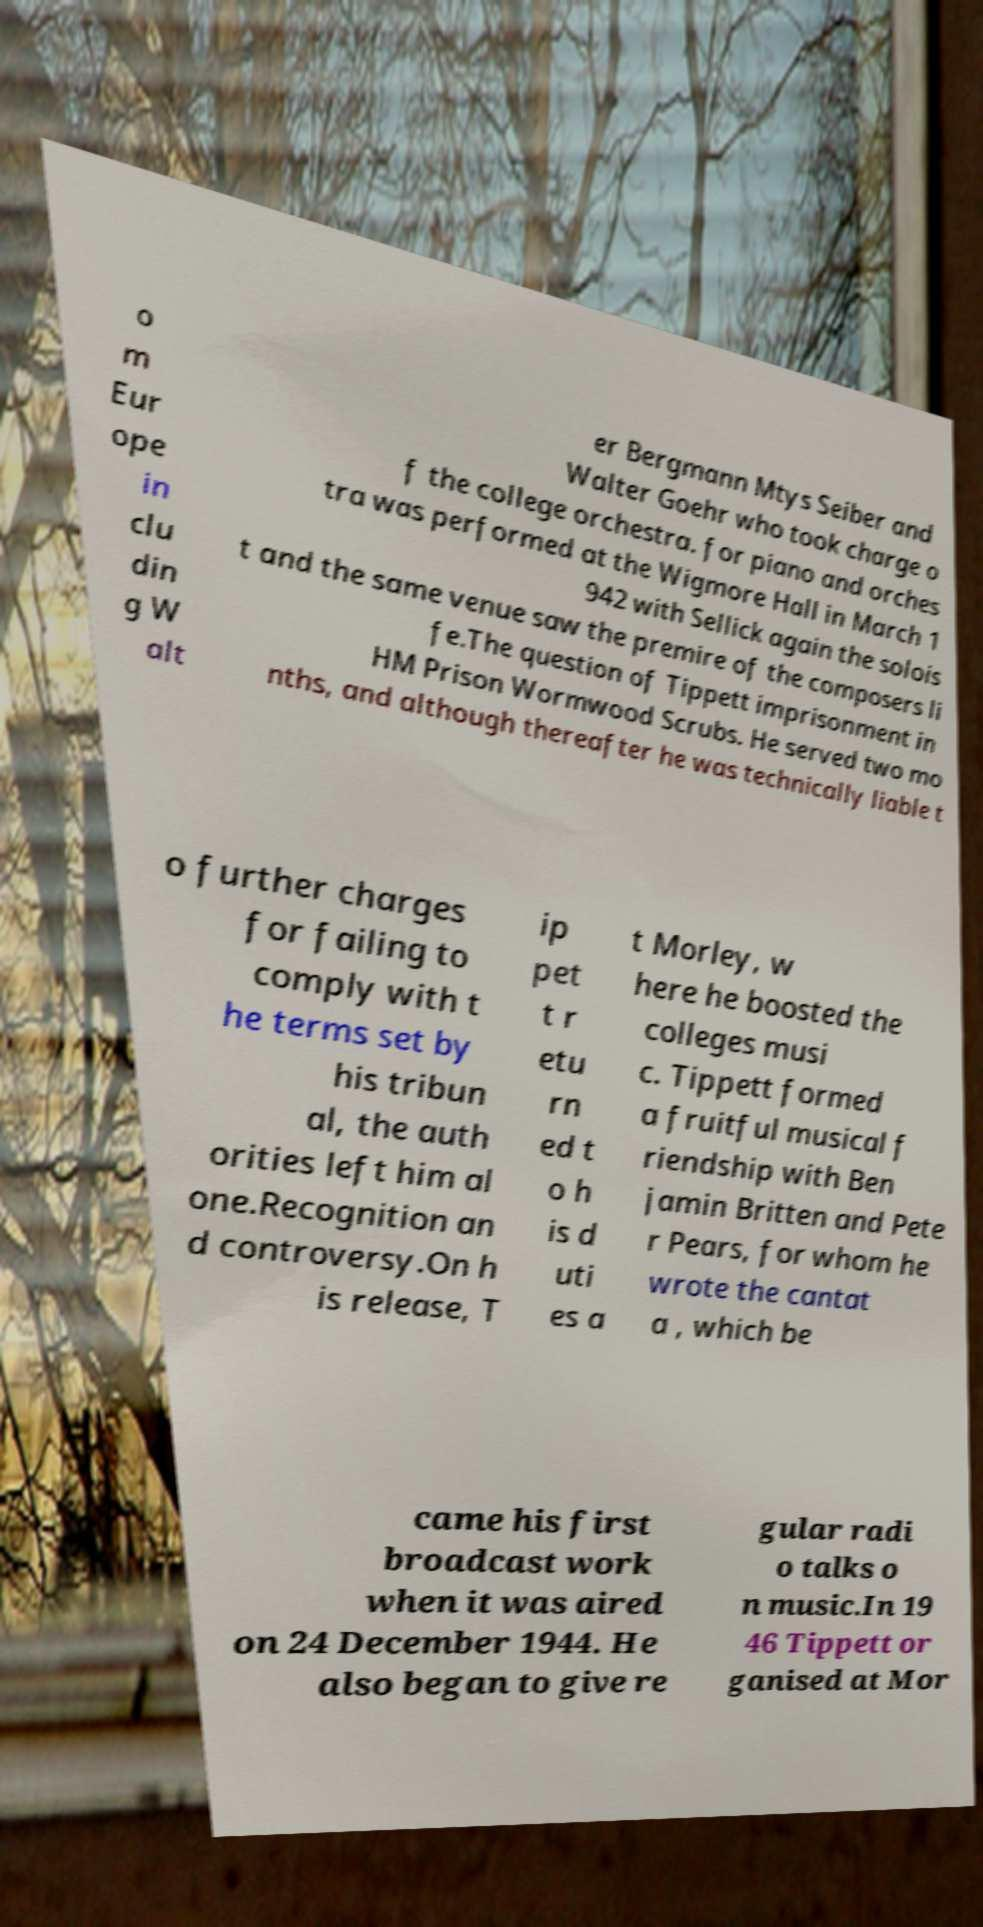Could you extract and type out the text from this image? o m Eur ope in clu din g W alt er Bergmann Mtys Seiber and Walter Goehr who took charge o f the college orchestra. for piano and orches tra was performed at the Wigmore Hall in March 1 942 with Sellick again the solois t and the same venue saw the premire of the composers li fe.The question of Tippett imprisonment in HM Prison Wormwood Scrubs. He served two mo nths, and although thereafter he was technically liable t o further charges for failing to comply with t he terms set by his tribun al, the auth orities left him al one.Recognition an d controversy.On h is release, T ip pet t r etu rn ed t o h is d uti es a t Morley, w here he boosted the colleges musi c. Tippett formed a fruitful musical f riendship with Ben jamin Britten and Pete r Pears, for whom he wrote the cantat a , which be came his first broadcast work when it was aired on 24 December 1944. He also began to give re gular radi o talks o n music.In 19 46 Tippett or ganised at Mor 